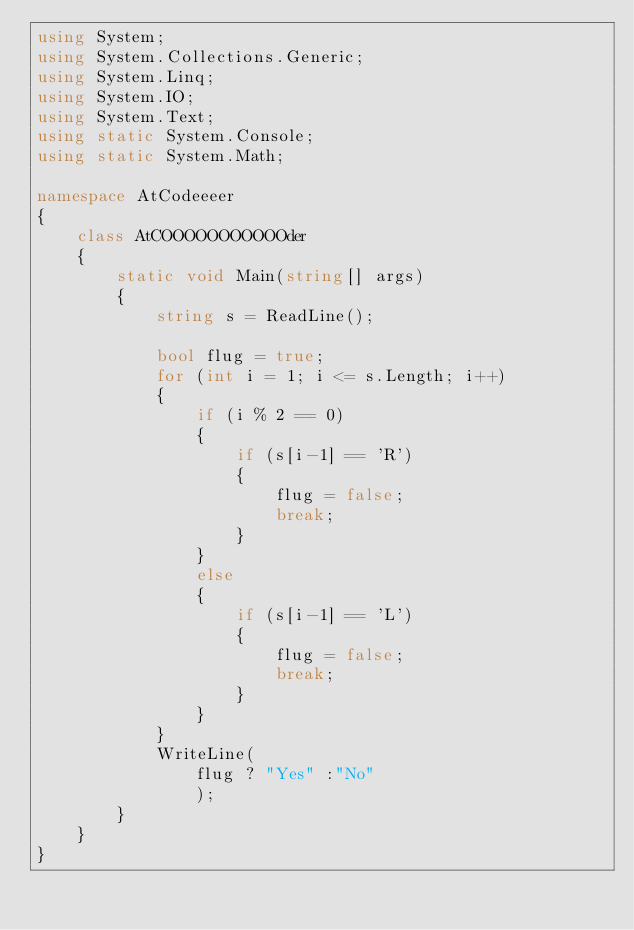<code> <loc_0><loc_0><loc_500><loc_500><_C#_>using System;
using System.Collections.Generic;
using System.Linq;
using System.IO;
using System.Text;
using static System.Console;
using static System.Math;

namespace AtCodeeeer
{
    class AtCOOOOOOOOOOOder
    {
        static void Main(string[] args)
        {
            string s = ReadLine();

            bool flug = true;
            for (int i = 1; i <= s.Length; i++)
            {
                if (i % 2 == 0)
                {
                    if (s[i-1] == 'R')
                    {
                        flug = false;
                        break;
                    }
                }
                else
                {
                    if (s[i-1] == 'L')
                    {
                        flug = false;
                        break;
                    }
                }
            }
            WriteLine(
                flug ? "Yes" :"No"
                );
        }
    }
}

</code> 